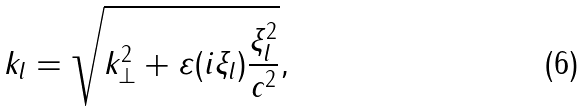Convert formula to latex. <formula><loc_0><loc_0><loc_500><loc_500>k _ { l } = \sqrt { k _ { \bot } ^ { 2 } + \varepsilon ( i \xi _ { l } ) \frac { \xi _ { l } ^ { 2 } } { c ^ { 2 } } } ,</formula> 